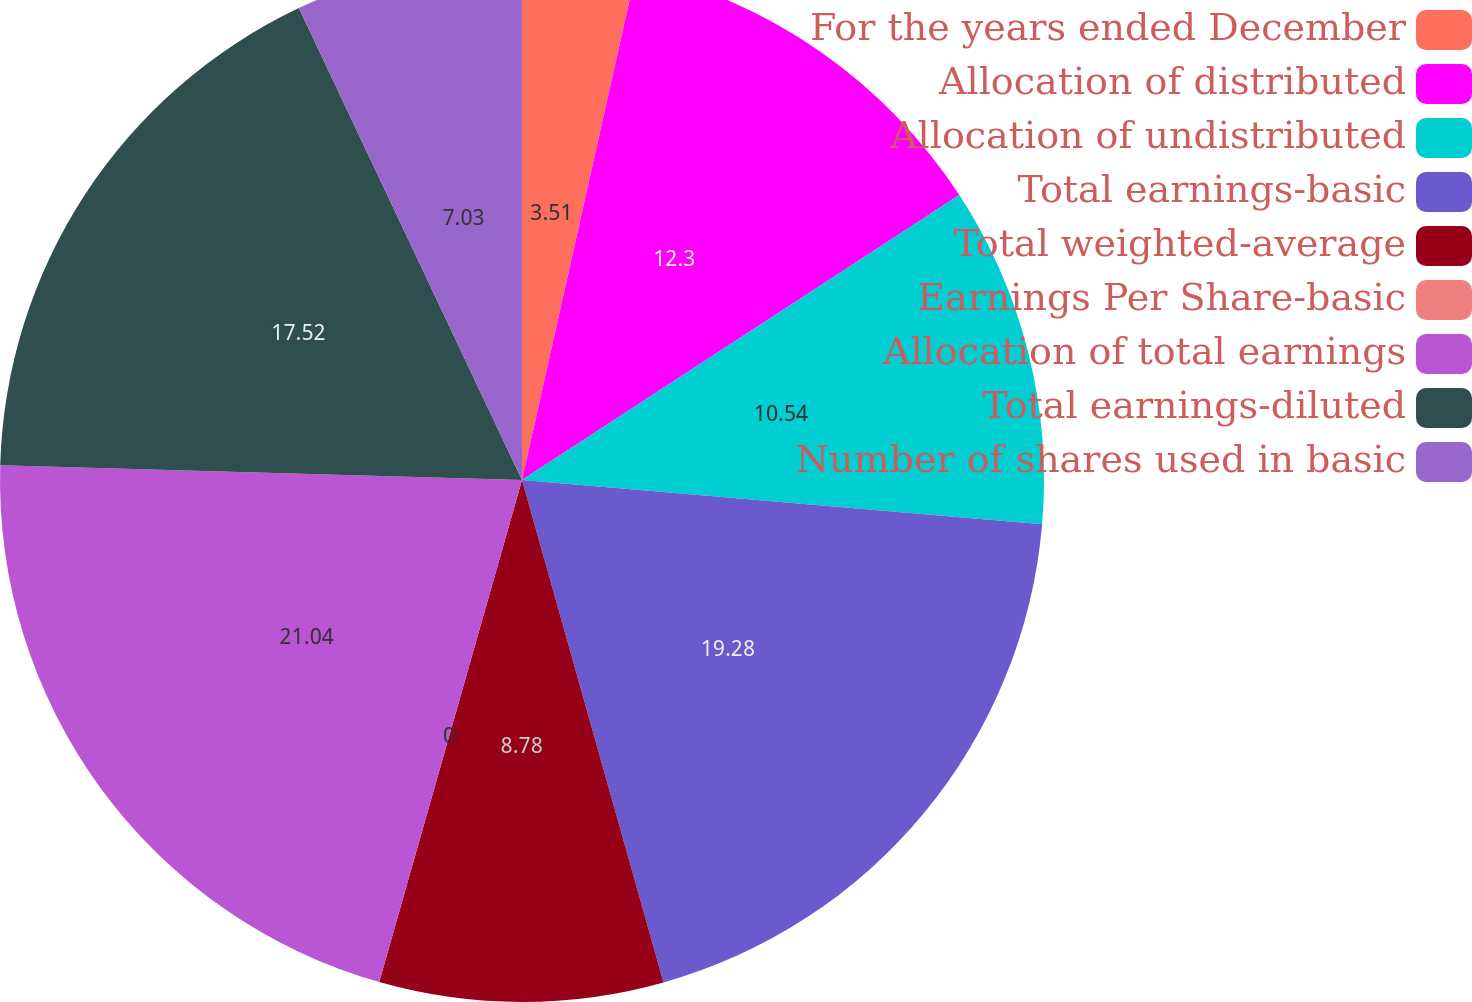Convert chart to OTSL. <chart><loc_0><loc_0><loc_500><loc_500><pie_chart><fcel>For the years ended December<fcel>Allocation of distributed<fcel>Allocation of undistributed<fcel>Total earnings-basic<fcel>Total weighted-average<fcel>Earnings Per Share-basic<fcel>Allocation of total earnings<fcel>Total earnings-diluted<fcel>Number of shares used in basic<nl><fcel>3.51%<fcel>12.3%<fcel>10.54%<fcel>19.28%<fcel>8.78%<fcel>0.0%<fcel>21.04%<fcel>17.52%<fcel>7.03%<nl></chart> 